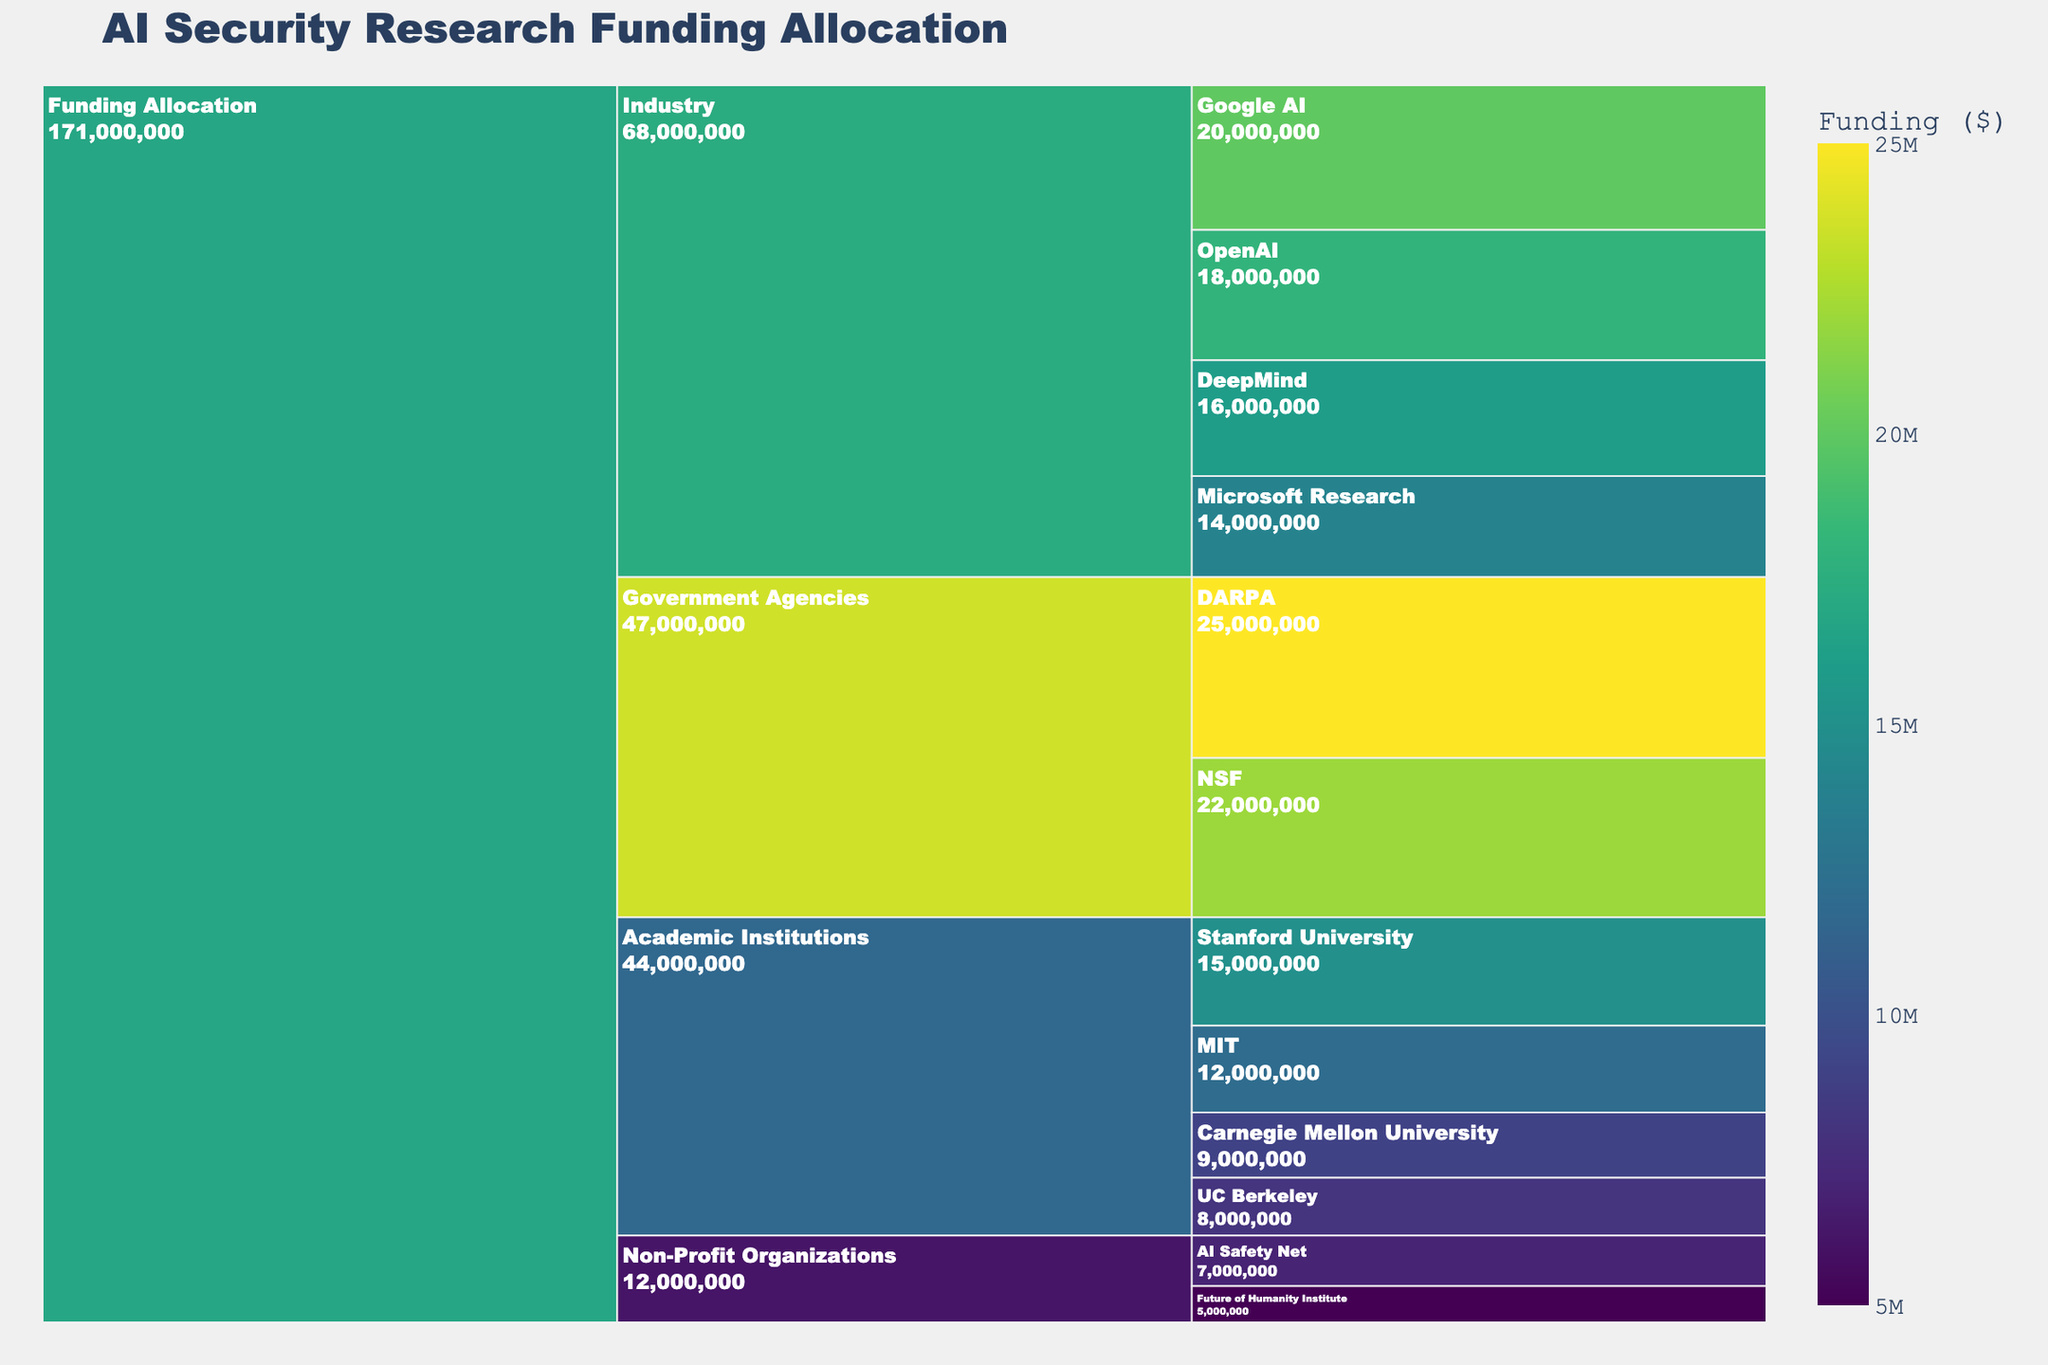What is the total funding allocated to academic institutions? Sum the funding amounts for all academic institutions: Stanford University ($15,000,000), MIT ($12,000,000), Carnegie Mellon University ($9,000,000), and UC Berkeley ($8,000,000). The total is $15,000,000 + $12,000,000 + $9,000,000 + $8,000,000 = $44,000,000.
Answer: $44,000,000 Which institution receives the highest funding among academic institutions? Compare the funding amounts: Stanford University ($15,000,000), MIT ($12,000,000), Carnegie Mellon University ($9,000,000), and UC Berkeley ($8,000,000). Stanford University has the highest funding of $15,000,000.
Answer: Stanford University How does the funding for industry compare to that for government agencies? Sum the funding for industry: Google AI ($20,000,000), OpenAI ($18,000,000), DeepMind ($16,000,000), and Microsoft Research ($14,000,000) total $68,000,000. Sum the funding for government agencies: DARPA ($25,000,000) and NSF ($22,000,000) total $47,000,000. Industry funding ($68,000,000) is greater than government agencies funding ($47,000,000).
Answer: Industry > Government Agencies What is the total funding for non-profit organizations? Sum the funding amounts for non-profit organizations: AI Safety Net ($7,000,000) and Future of Humanity Institute ($5,000,000). The total is $7,000,000 + $5,000,000 = $12,000,000.
Answer: $12,000,000 Which category has the largest overall funding? Compare the total funding amounts for each category: Academic Institutions ($44,000,000), Industry ($68,000,000), Government Agencies ($47,000,000), and Non-Profit Organizations ($12,000,000). Industry has the largest overall funding of $68,000,000.
Answer: Industry What funding amount separates the top two funded institutions in the industry category? Determine the top two funding amounts in the industry category: Google AI ($20,000,000) and OpenAI ($18,000,000). The difference is $20,000,000 - $18,000,000 = $2,000,000.
Answer: $2,000,000 What is the average funding per institution in academic institutions? Sum the funding for all academic institutions: Stanford University ($15,000,000), MIT ($12,000,000), Carnegie Mellon University ($9,000,000), UC Berkeley ($8,000,000) total $44,000,000. There are 4 institutions, so the average is $44,000,000 / 4 = $11,000,000.
Answer: $11,000,000 How much more funding does DARPA receive than the Future of Humanity Institute? Compare the funding for DARPA ($25,000,000) and the Future of Humanity Institute ($5,000,000). The difference is $25,000,000 - $5,000,000 = $20,000,000.
Answer: $20,000,000 Which category has the smallest number of subcategories? Count the subcategories per category: Academic Institutions (4), Industry (4), Government Agencies (2), Non-Profit Organizations (2). Government Agencies and Non-Profit Organizations both have the fewest subcategories, each with 2.
Answer: Government Agencies and Non-Profit Organizations 